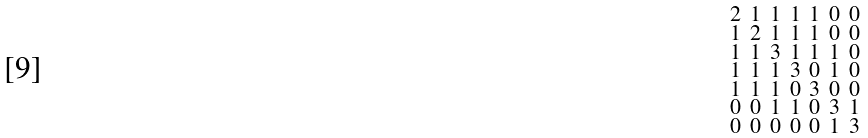Convert formula to latex. <formula><loc_0><loc_0><loc_500><loc_500>\begin{smallmatrix} 2 & 1 & 1 & 1 & 1 & 0 & 0 \\ 1 & 2 & 1 & 1 & 1 & 0 & 0 \\ 1 & 1 & 3 & 1 & 1 & 1 & 0 \\ 1 & 1 & 1 & 3 & 0 & 1 & 0 \\ 1 & 1 & 1 & 0 & 3 & 0 & 0 \\ 0 & 0 & 1 & 1 & 0 & 3 & 1 \\ 0 & 0 & 0 & 0 & 0 & 1 & 3 \end{smallmatrix}</formula> 